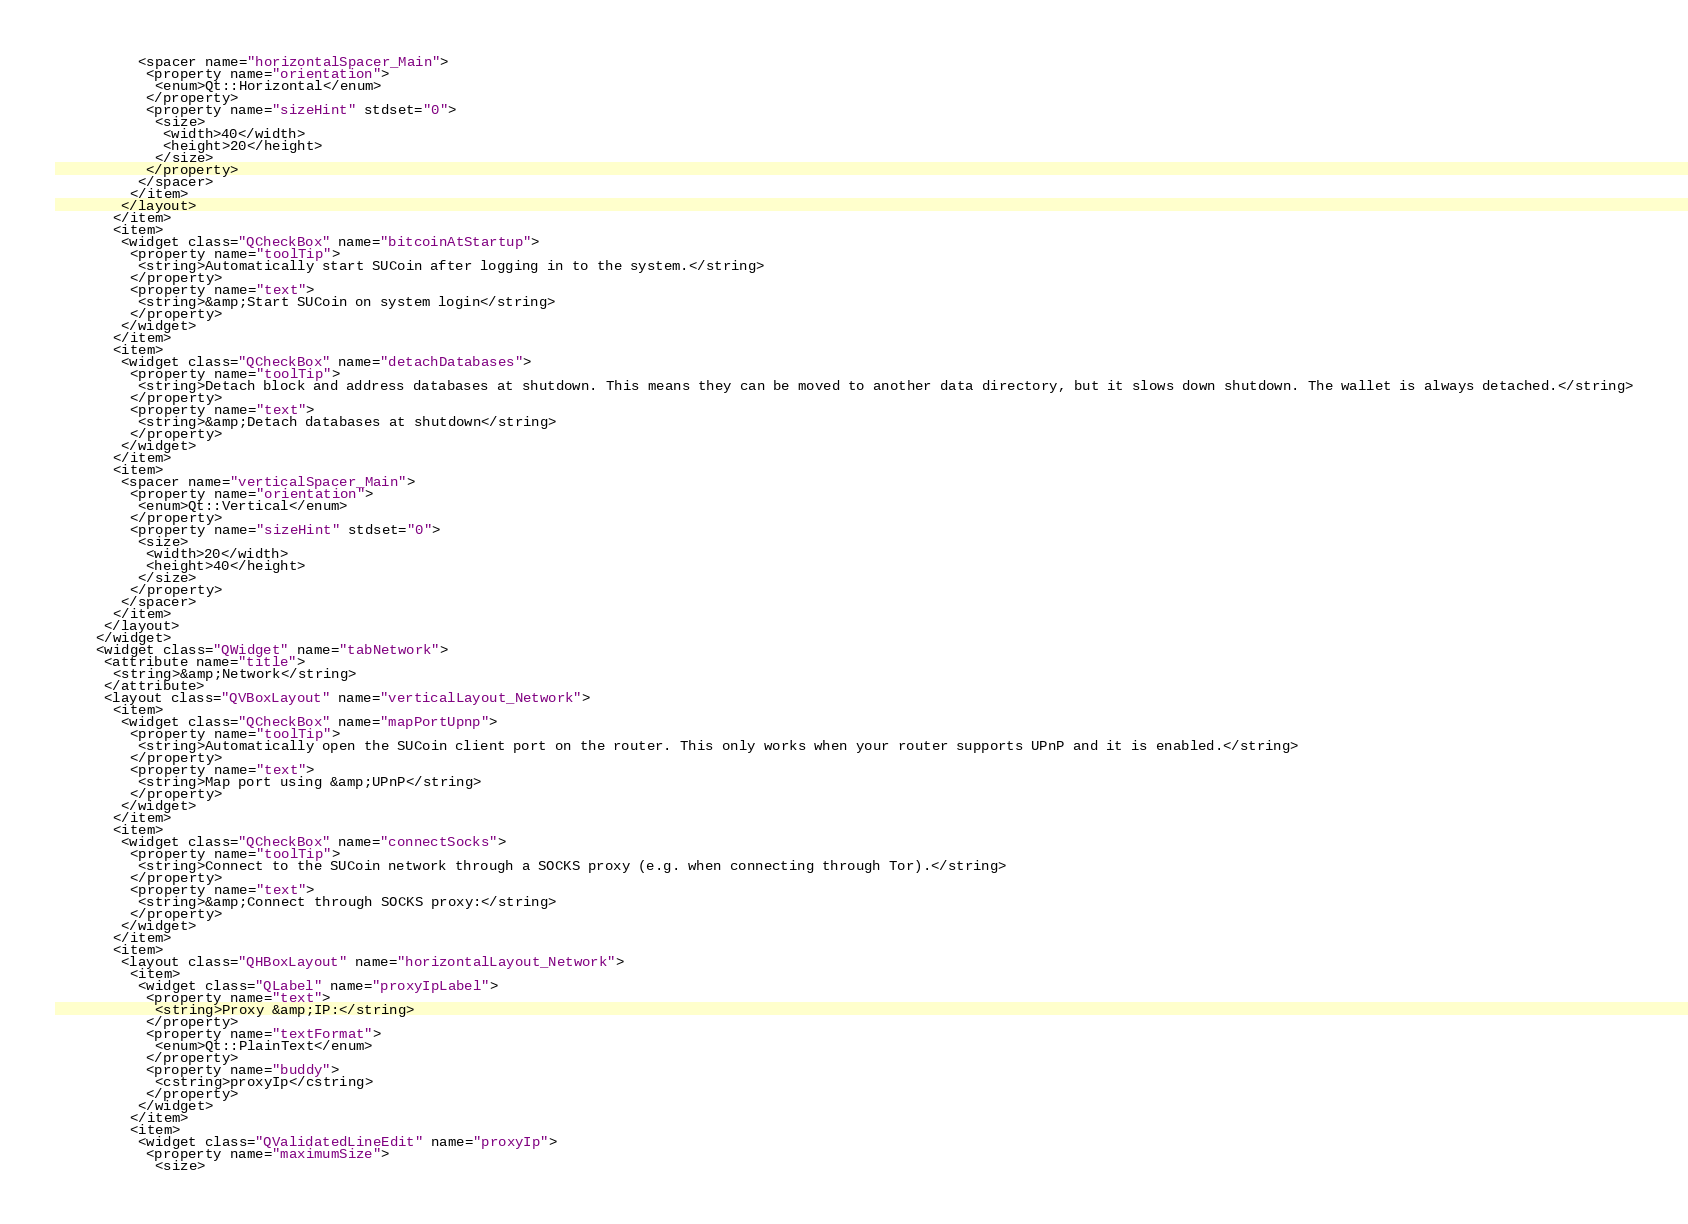<code> <loc_0><loc_0><loc_500><loc_500><_XML_>          <spacer name="horizontalSpacer_Main">
           <property name="orientation">
            <enum>Qt::Horizontal</enum>
           </property>
           <property name="sizeHint" stdset="0">
            <size>
             <width>40</width>
             <height>20</height>
            </size>
           </property>
          </spacer>
         </item>
        </layout>
       </item>
       <item>
        <widget class="QCheckBox" name="bitcoinAtStartup">
         <property name="toolTip">
          <string>Automatically start SUCoin after logging in to the system.</string>
         </property>
         <property name="text">
          <string>&amp;Start SUCoin on system login</string>
         </property>
        </widget>
       </item>
       <item>
        <widget class="QCheckBox" name="detachDatabases">
         <property name="toolTip">
          <string>Detach block and address databases at shutdown. This means they can be moved to another data directory, but it slows down shutdown. The wallet is always detached.</string>
         </property>
         <property name="text">
          <string>&amp;Detach databases at shutdown</string>
         </property>
        </widget>
       </item>
       <item>
        <spacer name="verticalSpacer_Main">
         <property name="orientation">
          <enum>Qt::Vertical</enum>
         </property>
         <property name="sizeHint" stdset="0">
          <size>
           <width>20</width>
           <height>40</height>
          </size>
         </property>
        </spacer>
       </item>
      </layout>
     </widget>
     <widget class="QWidget" name="tabNetwork">
      <attribute name="title">
       <string>&amp;Network</string>
      </attribute>
      <layout class="QVBoxLayout" name="verticalLayout_Network">
       <item>
        <widget class="QCheckBox" name="mapPortUpnp">
         <property name="toolTip">
          <string>Automatically open the SUCoin client port on the router. This only works when your router supports UPnP and it is enabled.</string>
         </property>
         <property name="text">
          <string>Map port using &amp;UPnP</string>
         </property>
        </widget>
       </item>
       <item>
        <widget class="QCheckBox" name="connectSocks">
         <property name="toolTip">
          <string>Connect to the SUCoin network through a SOCKS proxy (e.g. when connecting through Tor).</string>
         </property>
         <property name="text">
          <string>&amp;Connect through SOCKS proxy:</string>
         </property>
        </widget>
       </item>
       <item>
        <layout class="QHBoxLayout" name="horizontalLayout_Network">
         <item>
          <widget class="QLabel" name="proxyIpLabel">
           <property name="text">
            <string>Proxy &amp;IP:</string>
           </property>
           <property name="textFormat">
            <enum>Qt::PlainText</enum>
           </property>
           <property name="buddy">
            <cstring>proxyIp</cstring>
           </property>
          </widget>
         </item>
         <item>
          <widget class="QValidatedLineEdit" name="proxyIp">
           <property name="maximumSize">
            <size></code> 